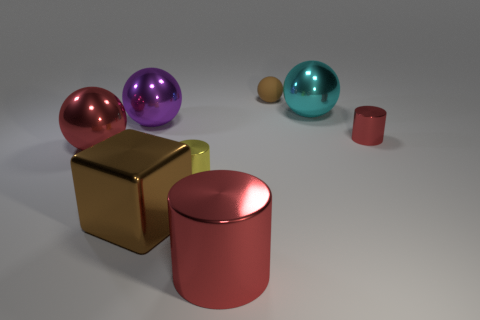There is a large thing that is both behind the tiny yellow cylinder and in front of the purple shiny ball; what is its color?
Ensure brevity in your answer.  Red. Are there any red metallic objects of the same shape as the big purple shiny object?
Ensure brevity in your answer.  Yes. What material is the small brown sphere?
Ensure brevity in your answer.  Rubber. Are there any small metal things on the right side of the small matte ball?
Keep it short and to the point. Yes. Do the small brown thing and the small yellow metallic thing have the same shape?
Your answer should be compact. No. What number of other objects are there of the same size as the yellow cylinder?
Your response must be concise. 2. How many objects are either brown things behind the cyan object or tiny green metallic objects?
Ensure brevity in your answer.  1. The big metal cylinder has what color?
Your answer should be very brief. Red. What is the large red object behind the big shiny cylinder made of?
Provide a succinct answer. Metal. Is the shape of the small brown object the same as the brown thing on the left side of the tiny brown matte object?
Provide a short and direct response. No. 